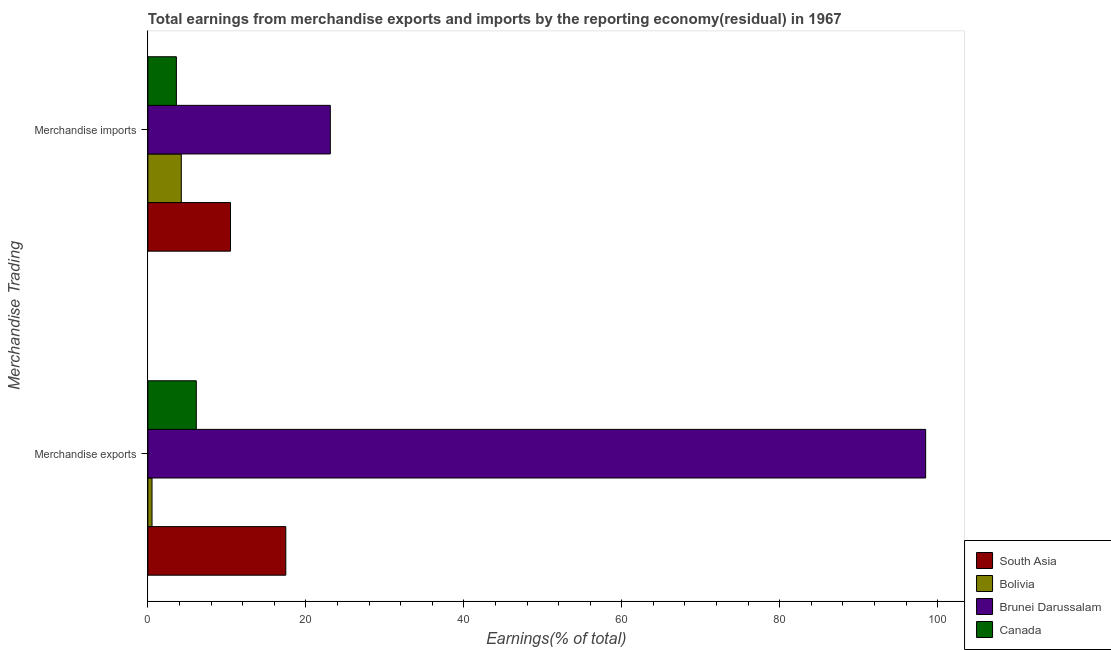Are the number of bars on each tick of the Y-axis equal?
Ensure brevity in your answer.  Yes. How many bars are there on the 1st tick from the bottom?
Your answer should be compact. 4. What is the earnings from merchandise imports in South Asia?
Your answer should be very brief. 10.46. Across all countries, what is the maximum earnings from merchandise exports?
Provide a succinct answer. 98.47. Across all countries, what is the minimum earnings from merchandise imports?
Offer a very short reply. 3.61. In which country was the earnings from merchandise imports maximum?
Your answer should be very brief. Brunei Darussalam. What is the total earnings from merchandise imports in the graph?
Provide a succinct answer. 41.4. What is the difference between the earnings from merchandise imports in South Asia and that in Brunei Darussalam?
Make the answer very short. -12.64. What is the difference between the earnings from merchandise imports in South Asia and the earnings from merchandise exports in Brunei Darussalam?
Your response must be concise. -88.01. What is the average earnings from merchandise exports per country?
Offer a terse response. 30.65. What is the difference between the earnings from merchandise imports and earnings from merchandise exports in Bolivia?
Provide a succinct answer. 3.71. What is the ratio of the earnings from merchandise imports in Bolivia to that in South Asia?
Give a very brief answer. 0.4. What does the 2nd bar from the top in Merchandise imports represents?
Your response must be concise. Brunei Darussalam. What does the 3rd bar from the bottom in Merchandise exports represents?
Your response must be concise. Brunei Darussalam. How many bars are there?
Give a very brief answer. 8. What is the difference between two consecutive major ticks on the X-axis?
Offer a very short reply. 20. Are the values on the major ticks of X-axis written in scientific E-notation?
Make the answer very short. No. Does the graph contain any zero values?
Your response must be concise. No. Does the graph contain grids?
Your response must be concise. No. Where does the legend appear in the graph?
Give a very brief answer. Bottom right. How are the legend labels stacked?
Make the answer very short. Vertical. What is the title of the graph?
Keep it short and to the point. Total earnings from merchandise exports and imports by the reporting economy(residual) in 1967. What is the label or title of the X-axis?
Keep it short and to the point. Earnings(% of total). What is the label or title of the Y-axis?
Your answer should be very brief. Merchandise Trading. What is the Earnings(% of total) in South Asia in Merchandise exports?
Ensure brevity in your answer.  17.46. What is the Earnings(% of total) of Bolivia in Merchandise exports?
Give a very brief answer. 0.53. What is the Earnings(% of total) in Brunei Darussalam in Merchandise exports?
Your answer should be compact. 98.47. What is the Earnings(% of total) of Canada in Merchandise exports?
Provide a succinct answer. 6.13. What is the Earnings(% of total) in South Asia in Merchandise imports?
Offer a terse response. 10.46. What is the Earnings(% of total) of Bolivia in Merchandise imports?
Your answer should be very brief. 4.23. What is the Earnings(% of total) in Brunei Darussalam in Merchandise imports?
Offer a very short reply. 23.1. What is the Earnings(% of total) of Canada in Merchandise imports?
Your answer should be compact. 3.61. Across all Merchandise Trading, what is the maximum Earnings(% of total) of South Asia?
Provide a short and direct response. 17.46. Across all Merchandise Trading, what is the maximum Earnings(% of total) in Bolivia?
Make the answer very short. 4.23. Across all Merchandise Trading, what is the maximum Earnings(% of total) in Brunei Darussalam?
Give a very brief answer. 98.47. Across all Merchandise Trading, what is the maximum Earnings(% of total) in Canada?
Ensure brevity in your answer.  6.13. Across all Merchandise Trading, what is the minimum Earnings(% of total) of South Asia?
Offer a terse response. 10.46. Across all Merchandise Trading, what is the minimum Earnings(% of total) of Bolivia?
Offer a terse response. 0.53. Across all Merchandise Trading, what is the minimum Earnings(% of total) of Brunei Darussalam?
Offer a very short reply. 23.1. Across all Merchandise Trading, what is the minimum Earnings(% of total) of Canada?
Offer a very short reply. 3.61. What is the total Earnings(% of total) of South Asia in the graph?
Provide a succinct answer. 27.92. What is the total Earnings(% of total) of Bolivia in the graph?
Your answer should be compact. 4.76. What is the total Earnings(% of total) of Brunei Darussalam in the graph?
Keep it short and to the point. 121.57. What is the total Earnings(% of total) in Canada in the graph?
Offer a terse response. 9.74. What is the difference between the Earnings(% of total) of South Asia in Merchandise exports and that in Merchandise imports?
Offer a very short reply. 7.01. What is the difference between the Earnings(% of total) in Bolivia in Merchandise exports and that in Merchandise imports?
Your response must be concise. -3.71. What is the difference between the Earnings(% of total) in Brunei Darussalam in Merchandise exports and that in Merchandise imports?
Provide a succinct answer. 75.37. What is the difference between the Earnings(% of total) in Canada in Merchandise exports and that in Merchandise imports?
Provide a succinct answer. 2.52. What is the difference between the Earnings(% of total) in South Asia in Merchandise exports and the Earnings(% of total) in Bolivia in Merchandise imports?
Your answer should be very brief. 13.23. What is the difference between the Earnings(% of total) of South Asia in Merchandise exports and the Earnings(% of total) of Brunei Darussalam in Merchandise imports?
Offer a very short reply. -5.64. What is the difference between the Earnings(% of total) in South Asia in Merchandise exports and the Earnings(% of total) in Canada in Merchandise imports?
Your response must be concise. 13.85. What is the difference between the Earnings(% of total) of Bolivia in Merchandise exports and the Earnings(% of total) of Brunei Darussalam in Merchandise imports?
Your response must be concise. -22.57. What is the difference between the Earnings(% of total) in Bolivia in Merchandise exports and the Earnings(% of total) in Canada in Merchandise imports?
Your answer should be very brief. -3.08. What is the difference between the Earnings(% of total) in Brunei Darussalam in Merchandise exports and the Earnings(% of total) in Canada in Merchandise imports?
Your response must be concise. 94.86. What is the average Earnings(% of total) of South Asia per Merchandise Trading?
Ensure brevity in your answer.  13.96. What is the average Earnings(% of total) in Bolivia per Merchandise Trading?
Provide a short and direct response. 2.38. What is the average Earnings(% of total) in Brunei Darussalam per Merchandise Trading?
Offer a very short reply. 60.79. What is the average Earnings(% of total) of Canada per Merchandise Trading?
Ensure brevity in your answer.  4.87. What is the difference between the Earnings(% of total) of South Asia and Earnings(% of total) of Bolivia in Merchandise exports?
Give a very brief answer. 16.94. What is the difference between the Earnings(% of total) of South Asia and Earnings(% of total) of Brunei Darussalam in Merchandise exports?
Provide a succinct answer. -81.01. What is the difference between the Earnings(% of total) of South Asia and Earnings(% of total) of Canada in Merchandise exports?
Make the answer very short. 11.33. What is the difference between the Earnings(% of total) of Bolivia and Earnings(% of total) of Brunei Darussalam in Merchandise exports?
Offer a terse response. -97.94. What is the difference between the Earnings(% of total) of Bolivia and Earnings(% of total) of Canada in Merchandise exports?
Your answer should be very brief. -5.6. What is the difference between the Earnings(% of total) of Brunei Darussalam and Earnings(% of total) of Canada in Merchandise exports?
Give a very brief answer. 92.34. What is the difference between the Earnings(% of total) of South Asia and Earnings(% of total) of Bolivia in Merchandise imports?
Provide a succinct answer. 6.22. What is the difference between the Earnings(% of total) of South Asia and Earnings(% of total) of Brunei Darussalam in Merchandise imports?
Offer a terse response. -12.64. What is the difference between the Earnings(% of total) of South Asia and Earnings(% of total) of Canada in Merchandise imports?
Your response must be concise. 6.85. What is the difference between the Earnings(% of total) in Bolivia and Earnings(% of total) in Brunei Darussalam in Merchandise imports?
Keep it short and to the point. -18.87. What is the difference between the Earnings(% of total) of Bolivia and Earnings(% of total) of Canada in Merchandise imports?
Provide a succinct answer. 0.62. What is the difference between the Earnings(% of total) in Brunei Darussalam and Earnings(% of total) in Canada in Merchandise imports?
Ensure brevity in your answer.  19.49. What is the ratio of the Earnings(% of total) of South Asia in Merchandise exports to that in Merchandise imports?
Provide a short and direct response. 1.67. What is the ratio of the Earnings(% of total) in Bolivia in Merchandise exports to that in Merchandise imports?
Provide a short and direct response. 0.12. What is the ratio of the Earnings(% of total) of Brunei Darussalam in Merchandise exports to that in Merchandise imports?
Provide a succinct answer. 4.26. What is the ratio of the Earnings(% of total) of Canada in Merchandise exports to that in Merchandise imports?
Your answer should be compact. 1.7. What is the difference between the highest and the second highest Earnings(% of total) of South Asia?
Provide a succinct answer. 7.01. What is the difference between the highest and the second highest Earnings(% of total) in Bolivia?
Your response must be concise. 3.71. What is the difference between the highest and the second highest Earnings(% of total) in Brunei Darussalam?
Provide a short and direct response. 75.37. What is the difference between the highest and the second highest Earnings(% of total) of Canada?
Your response must be concise. 2.52. What is the difference between the highest and the lowest Earnings(% of total) of South Asia?
Your response must be concise. 7.01. What is the difference between the highest and the lowest Earnings(% of total) of Bolivia?
Provide a succinct answer. 3.71. What is the difference between the highest and the lowest Earnings(% of total) of Brunei Darussalam?
Provide a short and direct response. 75.37. What is the difference between the highest and the lowest Earnings(% of total) in Canada?
Your response must be concise. 2.52. 